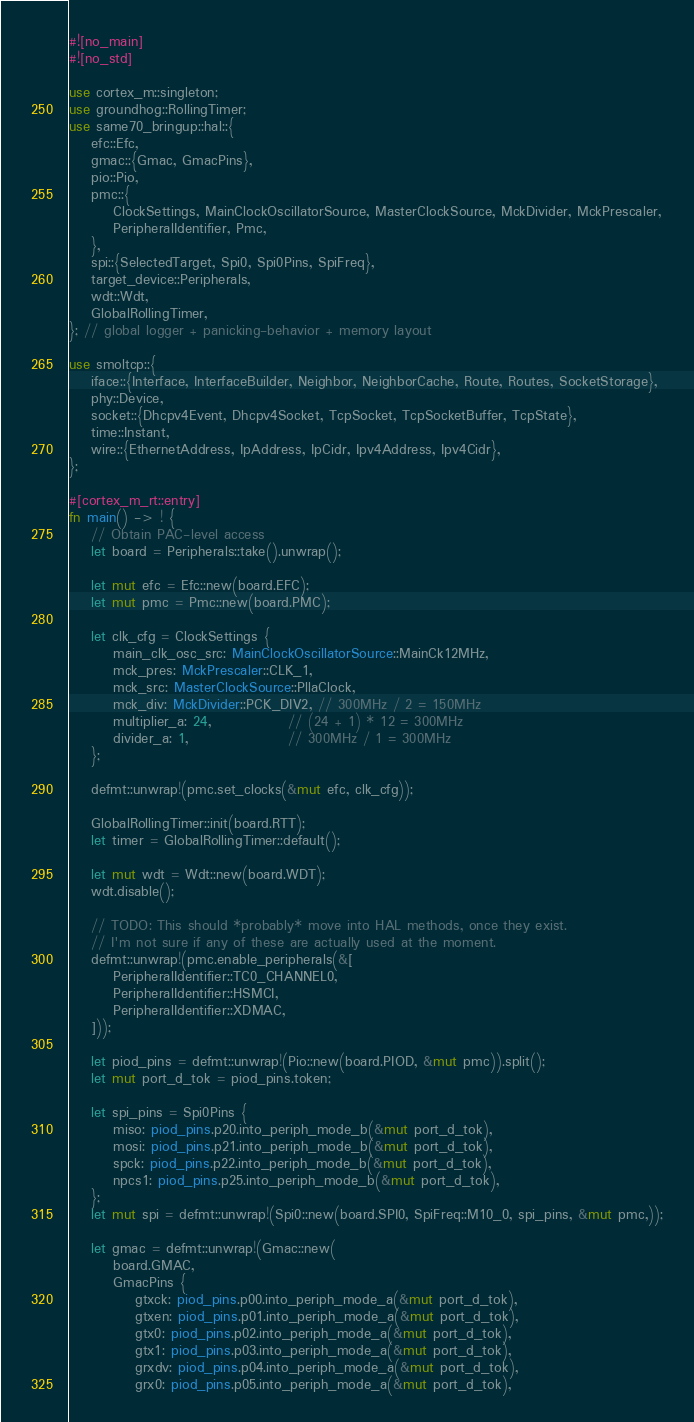<code> <loc_0><loc_0><loc_500><loc_500><_Rust_>#![no_main]
#![no_std]

use cortex_m::singleton;
use groundhog::RollingTimer;
use same70_bringup::hal::{
    efc::Efc,
    gmac::{Gmac, GmacPins},
    pio::Pio,
    pmc::{
        ClockSettings, MainClockOscillatorSource, MasterClockSource, MckDivider, MckPrescaler,
        PeripheralIdentifier, Pmc,
    },
    spi::{SelectedTarget, Spi0, Spi0Pins, SpiFreq},
    target_device::Peripherals,
    wdt::Wdt,
    GlobalRollingTimer,
}; // global logger + panicking-behavior + memory layout

use smoltcp::{
    iface::{Interface, InterfaceBuilder, Neighbor, NeighborCache, Route, Routes, SocketStorage},
    phy::Device,
    socket::{Dhcpv4Event, Dhcpv4Socket, TcpSocket, TcpSocketBuffer, TcpState},
    time::Instant,
    wire::{EthernetAddress, IpAddress, IpCidr, Ipv4Address, Ipv4Cidr},
};

#[cortex_m_rt::entry]
fn main() -> ! {
    // Obtain PAC-level access
    let board = Peripherals::take().unwrap();

    let mut efc = Efc::new(board.EFC);
    let mut pmc = Pmc::new(board.PMC);

    let clk_cfg = ClockSettings {
        main_clk_osc_src: MainClockOscillatorSource::MainCk12MHz,
        mck_pres: MckPrescaler::CLK_1,
        mck_src: MasterClockSource::PllaClock,
        mck_div: MckDivider::PCK_DIV2, // 300MHz / 2 = 150MHz
        multiplier_a: 24,              // (24 + 1) * 12 = 300MHz
        divider_a: 1,                  // 300MHz / 1 = 300MHz
    };

    defmt::unwrap!(pmc.set_clocks(&mut efc, clk_cfg));

    GlobalRollingTimer::init(board.RTT);
    let timer = GlobalRollingTimer::default();

    let mut wdt = Wdt::new(board.WDT);
    wdt.disable();

    // TODO: This should *probably* move into HAL methods, once they exist.
    // I'm not sure if any of these are actually used at the moment.
    defmt::unwrap!(pmc.enable_peripherals(&[
        PeripheralIdentifier::TC0_CHANNEL0,
        PeripheralIdentifier::HSMCI,
        PeripheralIdentifier::XDMAC,
    ]));

    let piod_pins = defmt::unwrap!(Pio::new(board.PIOD, &mut pmc)).split();
    let mut port_d_tok = piod_pins.token;

    let spi_pins = Spi0Pins {
        miso: piod_pins.p20.into_periph_mode_b(&mut port_d_tok),
        mosi: piod_pins.p21.into_periph_mode_b(&mut port_d_tok),
        spck: piod_pins.p22.into_periph_mode_b(&mut port_d_tok),
        npcs1: piod_pins.p25.into_periph_mode_b(&mut port_d_tok),
    };
    let mut spi = defmt::unwrap!(Spi0::new(board.SPI0, SpiFreq::M10_0, spi_pins, &mut pmc,));

    let gmac = defmt::unwrap!(Gmac::new(
        board.GMAC,
        GmacPins {
            gtxck: piod_pins.p00.into_periph_mode_a(&mut port_d_tok),
            gtxen: piod_pins.p01.into_periph_mode_a(&mut port_d_tok),
            gtx0: piod_pins.p02.into_periph_mode_a(&mut port_d_tok),
            gtx1: piod_pins.p03.into_periph_mode_a(&mut port_d_tok),
            grxdv: piod_pins.p04.into_periph_mode_a(&mut port_d_tok),
            grx0: piod_pins.p05.into_periph_mode_a(&mut port_d_tok),</code> 